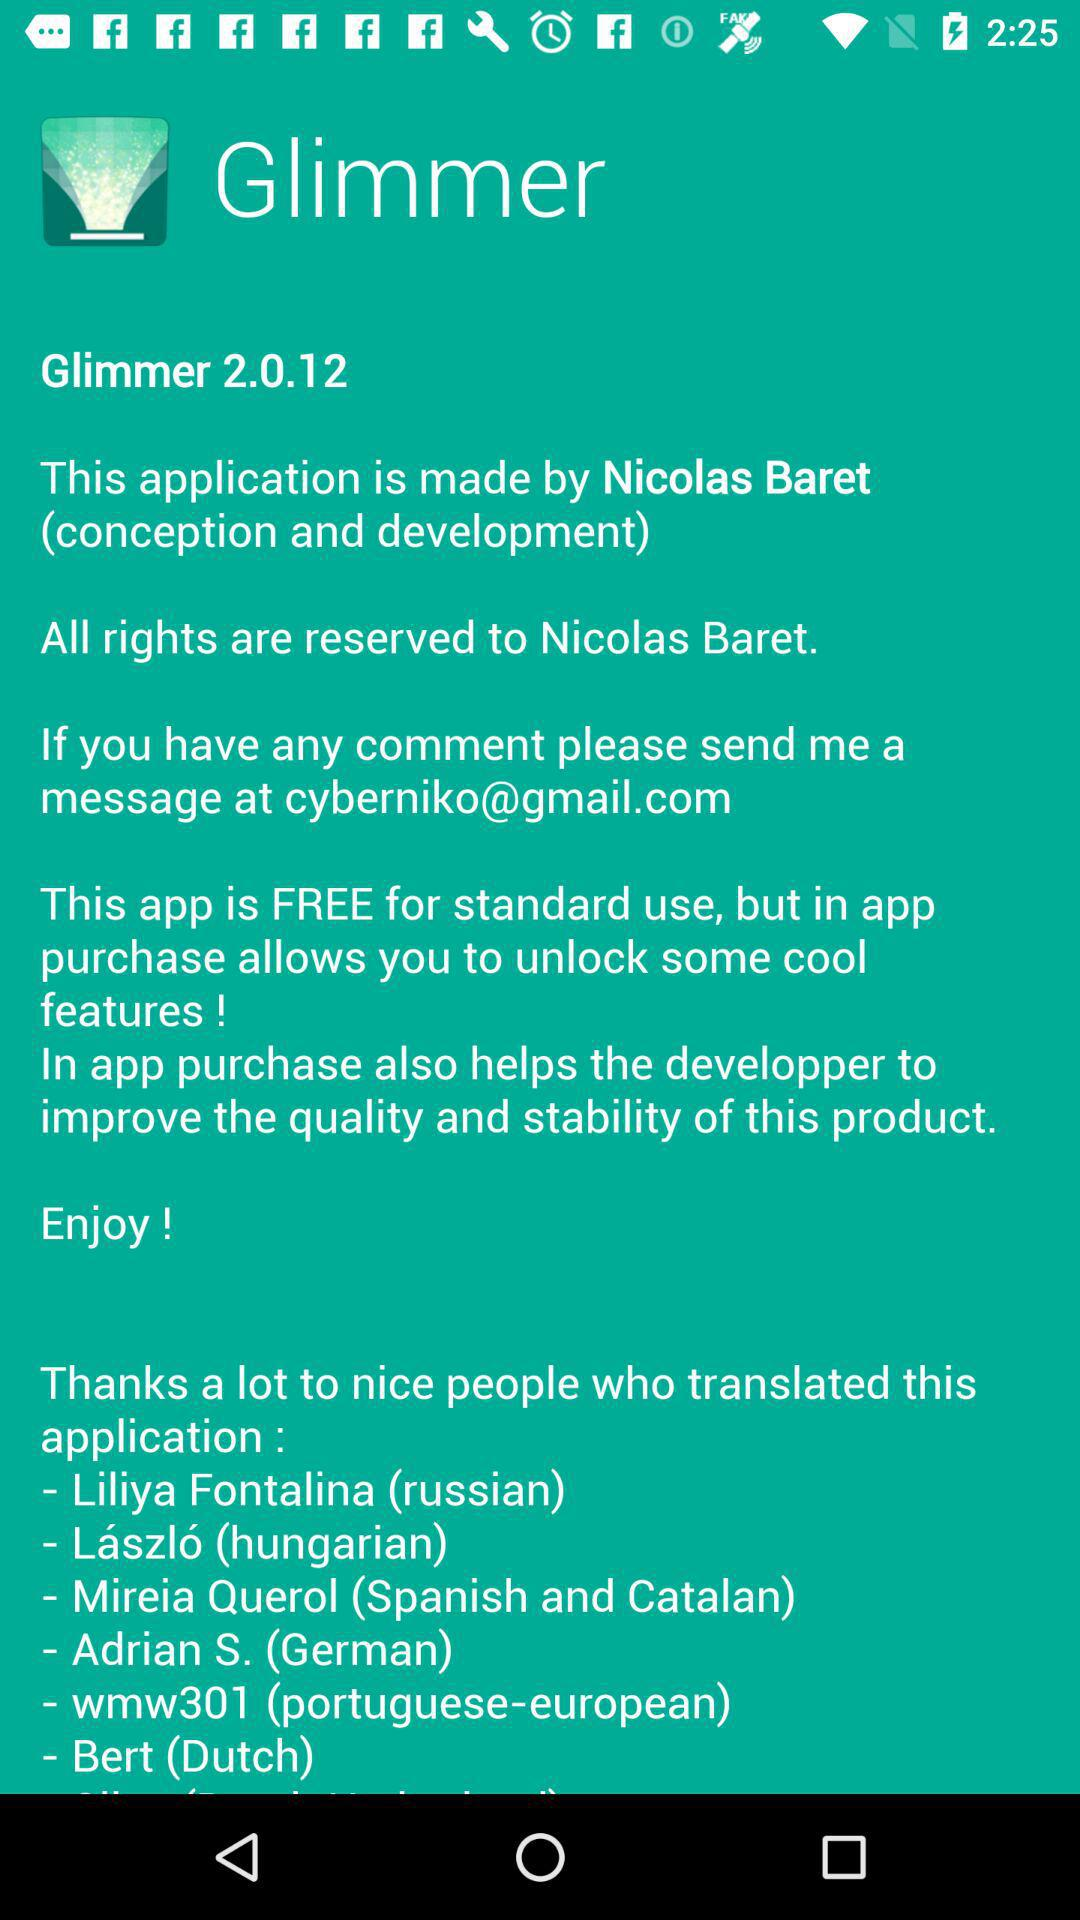Who is the Dutch translator? The Dutch translator is Bert. 